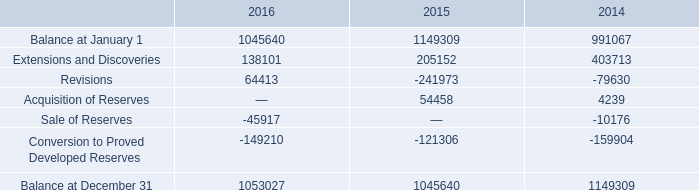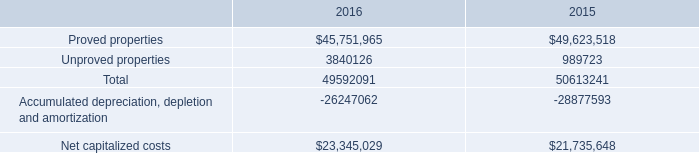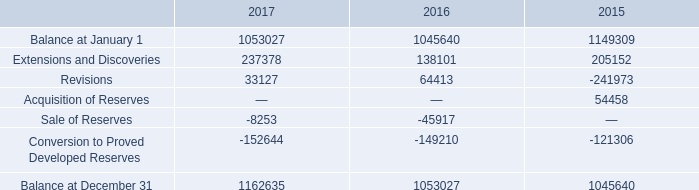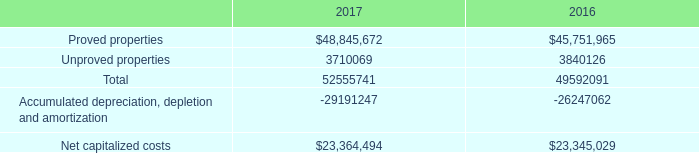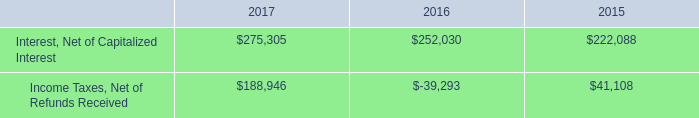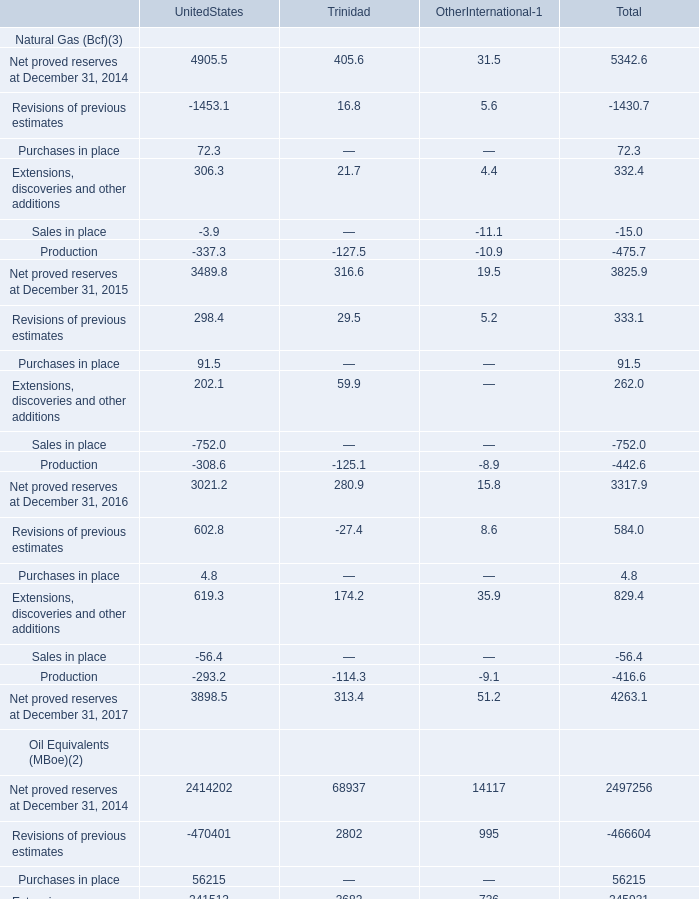How much of Extensions, discoveries and other additions is there in total (in 2015) without Trinidad and Other international? 
Answer: 306.3. 